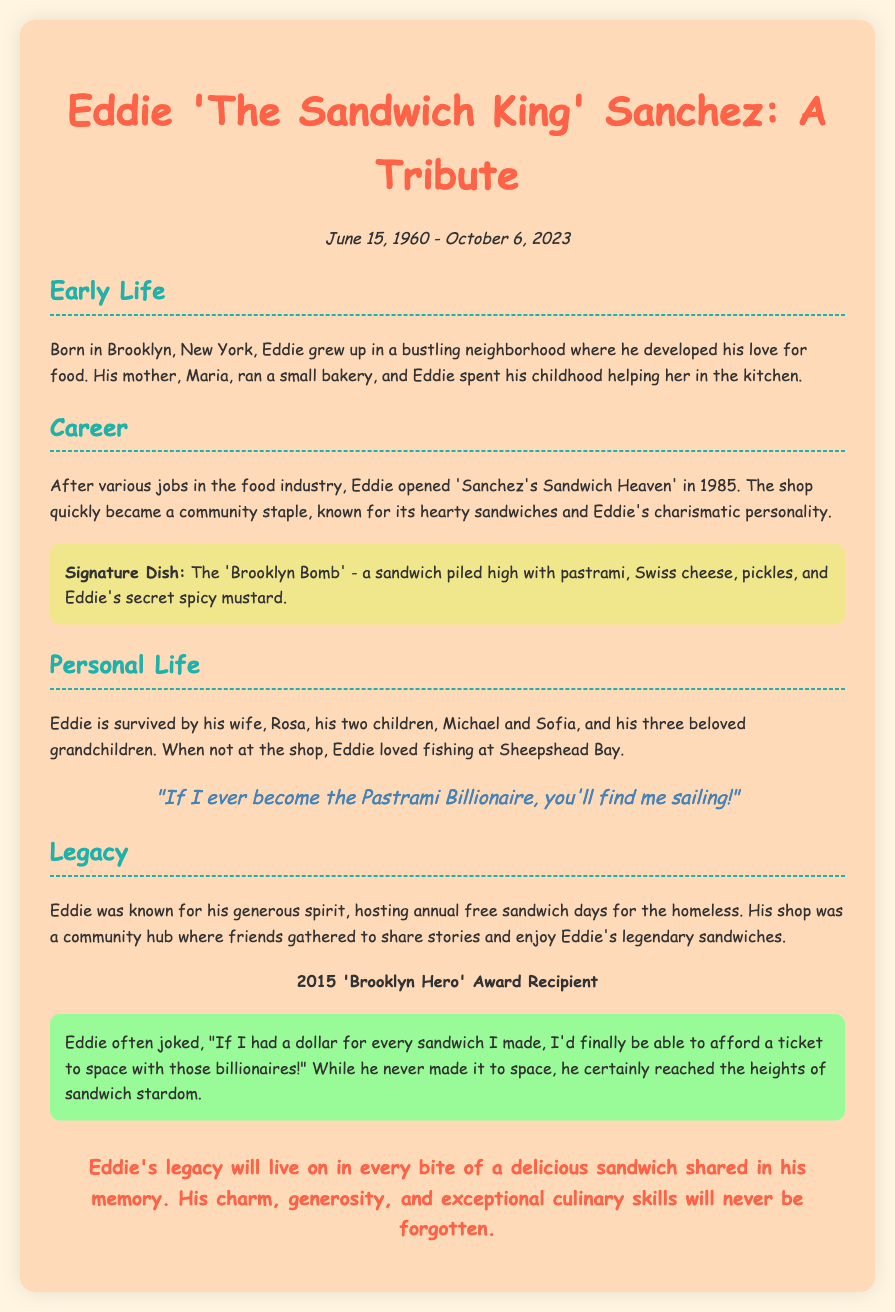What was Eddie's signature dish? The signature dish, mentioned in the document, is a specific sandwich known for its ingredients.
Answer: The 'Brooklyn Bomb' When did Eddie open his sandwich shop? The document states the year Eddie opened his shop, which marks the beginning of his career as a shop owner.
Answer: 1985 What was the award Eddie received in 2015? The document lists a specific award that Eddie received, highlighting his contributions to the community.
Answer: 'Brooklyn Hero' Award What humorous statement did Eddie make about billionaires? The document includes a humorous quote from Eddie, illustrating his witty personality.
Answer: "If I had a dollar for every sandwich I made, I'd finally be able to afford a ticket to space with those billionaires!" How many children did Eddie have? The document mentions the number of Eddie's children, which is part of his personal life details.
Answer: Two What was Eddie's place of birth? The document provides information about Eddie's early life, including his birthplace.
Answer: Brooklyn, New York What type of shop was 'Sanchez's Sandwich Heaven'? The document describes the nature of Eddie's shop and its importance in the community.
Answer: A sandwich shop How many grandchildren did Eddie have? The document includes personal details about Eddie's family, specifically the number of grandchildren.
Answer: Three 